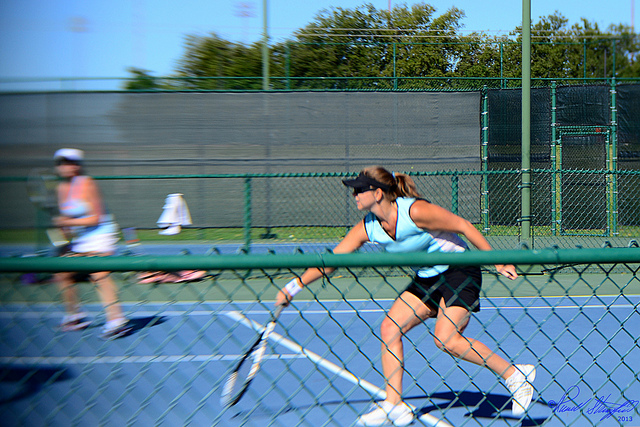What type of tennis shot is the player in the foreground likely executing in this photo? From the player's stance and racquet positioning, it appears she is preparing for a backhand shot, which is a stroke hit with the back of the dominant hand facing the direction of the shot. 